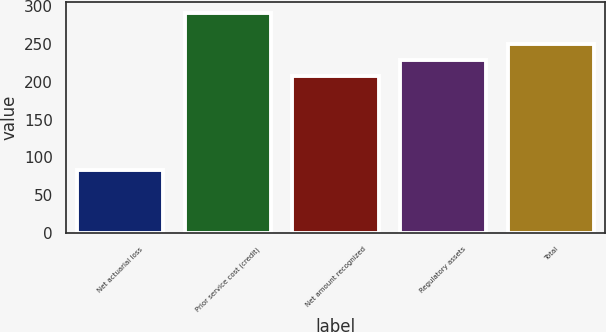Convert chart to OTSL. <chart><loc_0><loc_0><loc_500><loc_500><bar_chart><fcel>Net actuarial loss<fcel>Prior service cost (credit)<fcel>Net amount recognized<fcel>Regulatory assets<fcel>Total<nl><fcel>83<fcel>291<fcel>208<fcel>228.8<fcel>249.6<nl></chart> 